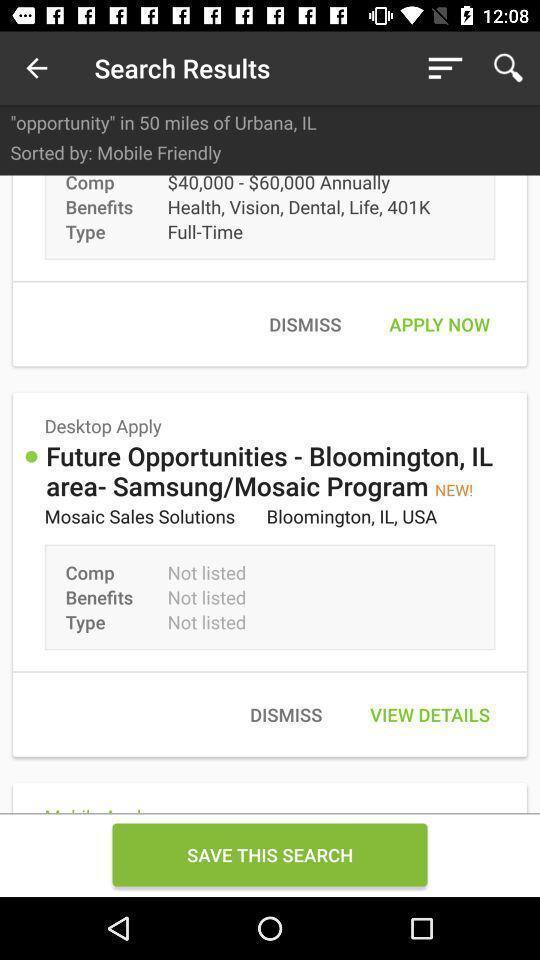Explain what's happening in this screen capture. Page displaying search results. 